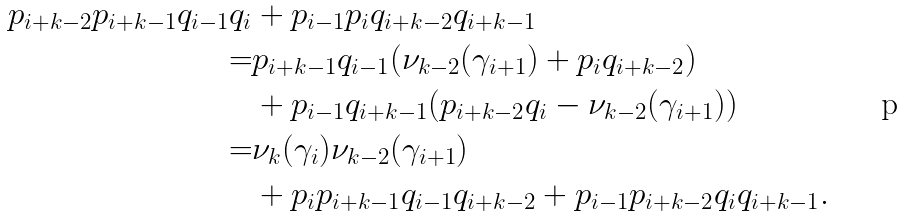<formula> <loc_0><loc_0><loc_500><loc_500>p _ { i + k - 2 } p _ { i + k - 1 } q _ { i - 1 } q _ { i } & + p _ { i - 1 } p _ { i } q _ { i + k - 2 } q _ { i + k - 1 } \\ = & p _ { i + k - 1 } q _ { i - 1 } ( \nu _ { k - 2 } ( \gamma _ { i + 1 } ) + p _ { i } q _ { i + k - 2 } ) \\ & + p _ { i - 1 } q _ { i + k - 1 } ( p _ { i + k - 2 } q _ { i } - \nu _ { k - 2 } ( \gamma _ { i + 1 } ) ) \\ = & \nu _ { k } ( \gamma _ { i } ) \nu _ { k - 2 } ( \gamma _ { i + 1 } ) \\ & + p _ { i } p _ { i + k - 1 } q _ { i - 1 } q _ { i + k - 2 } + p _ { i - 1 } p _ { i + k - 2 } q _ { i } q _ { i + k - 1 } .</formula> 